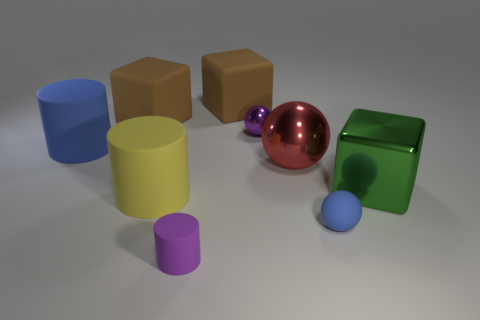There is a blue ball in front of the blue cylinder; does it have the same size as the yellow matte cylinder? The blue ball appears to be smaller in size compared to the yellow matte cylinder. While the ball and cylinder have different shapes which make a direct comparison challenging, the dimensions of the ball's diameter look to be less than the height or diameter of the yellow cylinder, indicating that the two objects do not share the same size. 